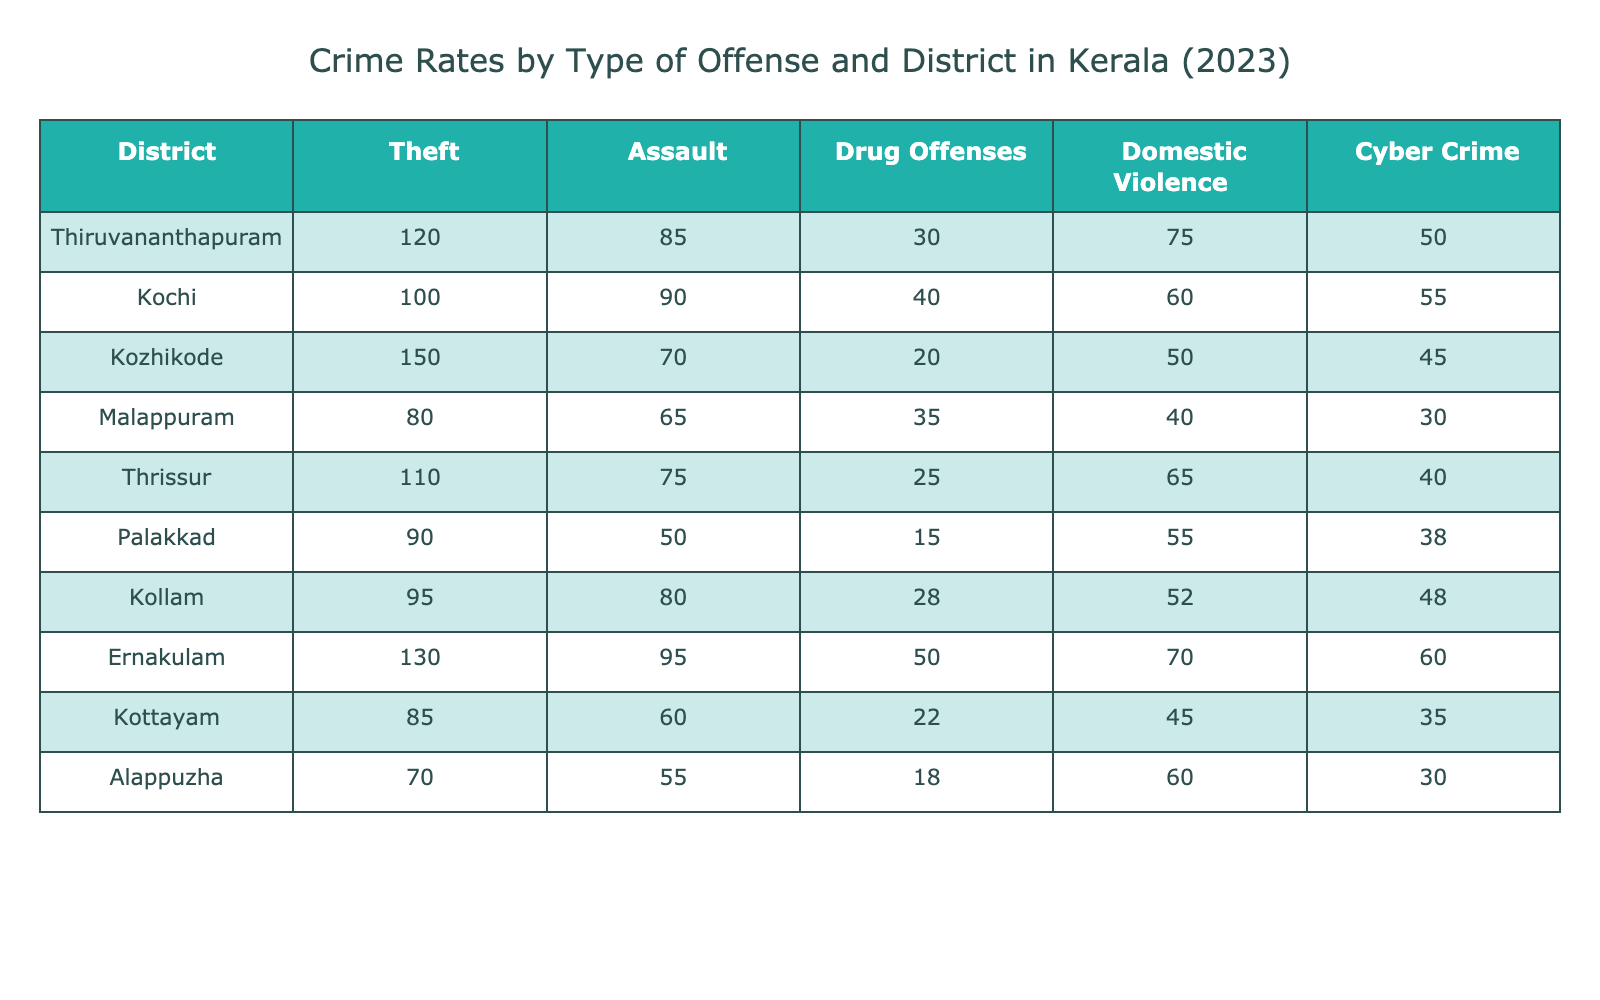What is the highest number of thefts reported in a district? By observing the column for Theft, the maximum value can be identified. The values are 120, 100, 150, 80, 110, 90, 95, 130, 85, and 70. The highest value is 150 in Kozhikode.
Answer: 150 Which district has the lowest reported cases of drug offenses? Looking at the Drug Offenses column, the values are 30, 40, 20, 35, 25, 15, 28, 50, 22, and 18. The minimum value among these is 15, which is found in Palakkad.
Answer: Palakkad Is it true that Kochi has more assaults than domestic violence cases? In Kochi, the values for Assault and Domestic Violence are 90 and 60, respectively. Since 90 is greater than 60, the statement is true.
Answer: Yes What is the total number of cyber crimes reported across all districts? To find the total, I sum the values in the Cyber Crime column: 50 + 55 + 45 + 30 + 40 + 38 + 48 + 60 + 35 + 30 =  429.
Answer: 429 Which district reports the highest number of domestic violence cases, and what is that number? By examining the Domestic Violence column, the values are 75, 60, 50, 40, 65, 55, 52, 70, 45, and 60. The highest value is 75 in Thiruvananthapuram.
Answer: Thiruvananthapuram, 75 What is the average number of assault incidents reported across the districts? To find the average, add the values for Assault (85 + 90 + 70 + 65 + 75 + 50 + 80 + 95 + 60 + 55 =  825) and divide by the number of districts (10), which results in an average of 82.5.
Answer: 82.5 If we consider only the districts with more than 100 thefts, which districts do they include? The districts with thefts over 100 are Thiruvananthapuram (120), Kozhikode (150), Ernakulam (130).
Answer: Thiruvananthapuram, Kozhikode, Ernakulam Which district has the second highest number of drug offenses? Ranking the drug offense values results in 50 (Ernakulam), 40 (Kochi), 35 (Malappuram), 30 (Thiruvananthapuram), 25 (Thrissur), 22 (Kottayam), 20 (Kozhikode), 18 (Alappuzha), 15 (Palakkad), and 28 (Kollam). Thus, the second highest is Kochi with 40.
Answer: Kochi What is the difference in the number of thefts between Thiruvananthapuram and Palakkad? The number of thefts in Thiruvananthapuram is 120, while in Palakkad, it is 90. The difference is calculated by subtracting: 120 - 90 = 30.
Answer: 30 